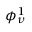Convert formula to latex. <formula><loc_0><loc_0><loc_500><loc_500>\phi _ { \nu } ^ { 1 }</formula> 